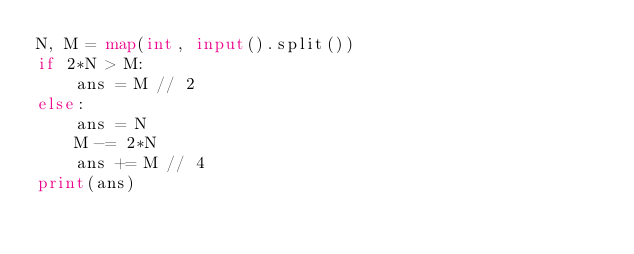<code> <loc_0><loc_0><loc_500><loc_500><_Python_>N, M = map(int, input().split())
if 2*N > M:
    ans = M // 2
else:
    ans = N
    M -= 2*N
    ans += M // 4
print(ans)</code> 